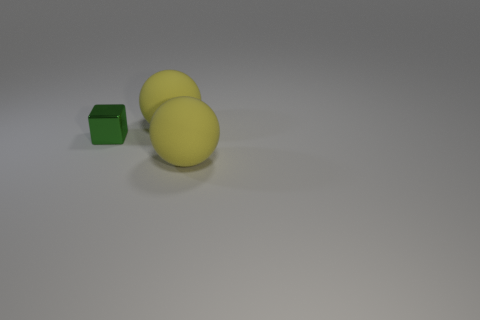What shape is the tiny green object that is behind the thing that is right of the large ball that is behind the small shiny cube?
Provide a succinct answer. Cube. There is a small metal object that is in front of the large yellow matte sphere behind the block; how many yellow things are in front of it?
Provide a short and direct response. 1. What number of big things are green cubes or yellow balls?
Your response must be concise. 2. Are the large yellow sphere that is behind the small green block and the tiny green cube made of the same material?
Your answer should be very brief. No. What material is the yellow thing behind the yellow sphere that is in front of the large rubber thing behind the small green metal object made of?
Offer a terse response. Rubber. Is there any other thing that has the same size as the green thing?
Provide a succinct answer. No. What number of shiny objects are either green objects or large balls?
Keep it short and to the point. 1. Is there a gray thing?
Provide a succinct answer. No. What color is the object to the right of the big yellow rubber thing behind the tiny block?
Keep it short and to the point. Yellow. What number of other objects are there of the same color as the cube?
Keep it short and to the point. 0. 